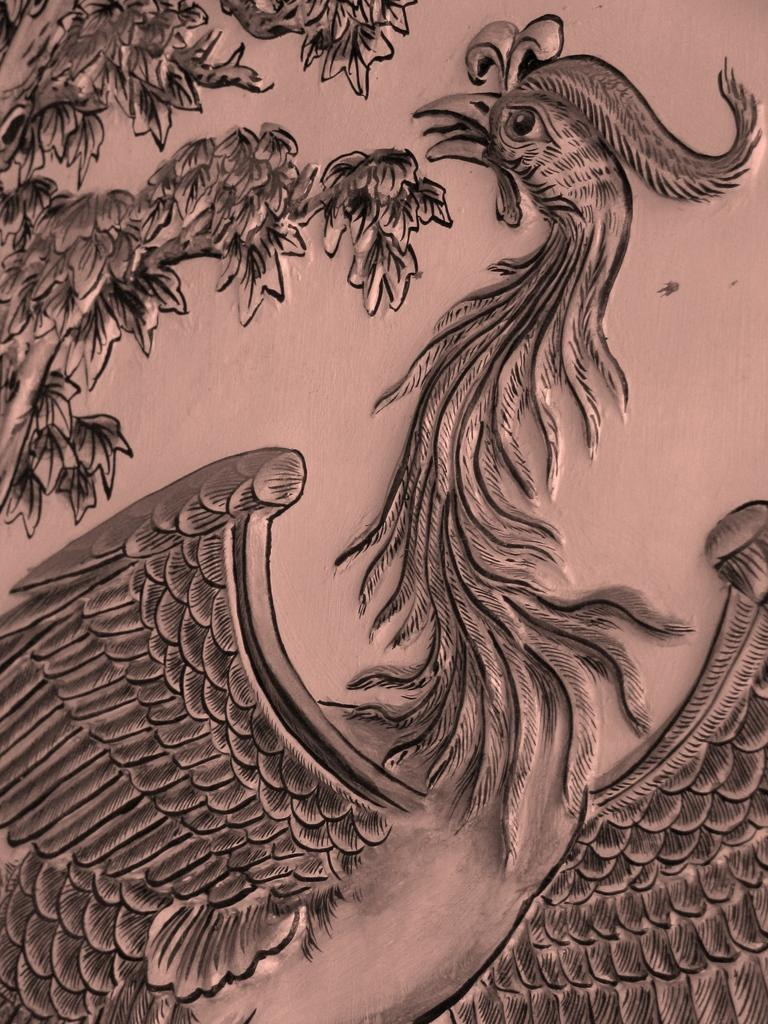What is the main subject of the image? There is a painting in the center of the image. What is the wealth distribution like in the aftermath of the change depicted in the painting? The image does not depict any wealth distribution, change, or aftermath; it only features a painting. 